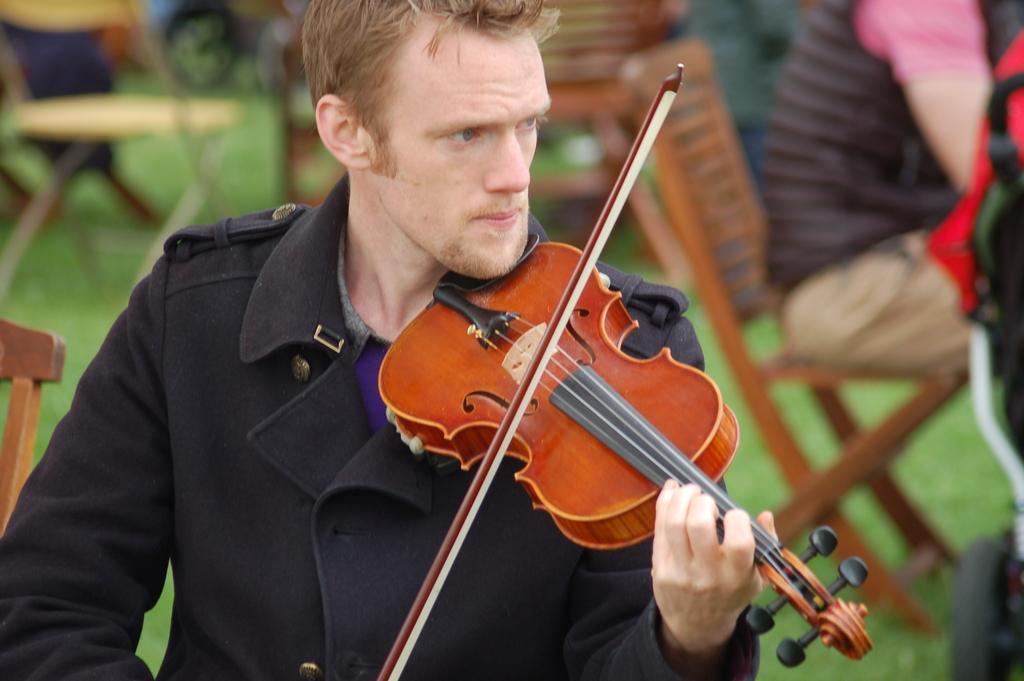Can you describe this image briefly? In this image a man is holding a violin in his hand and playing a music. In the right side of the image a man is sitting on a chair. At the bottom of the image there is a ground with grass. At the background there are few tables and empty chairs. 